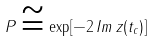<formula> <loc_0><loc_0><loc_500><loc_500>P \cong \exp [ - 2 \, I m \, z ( t _ { c } ) ]</formula> 